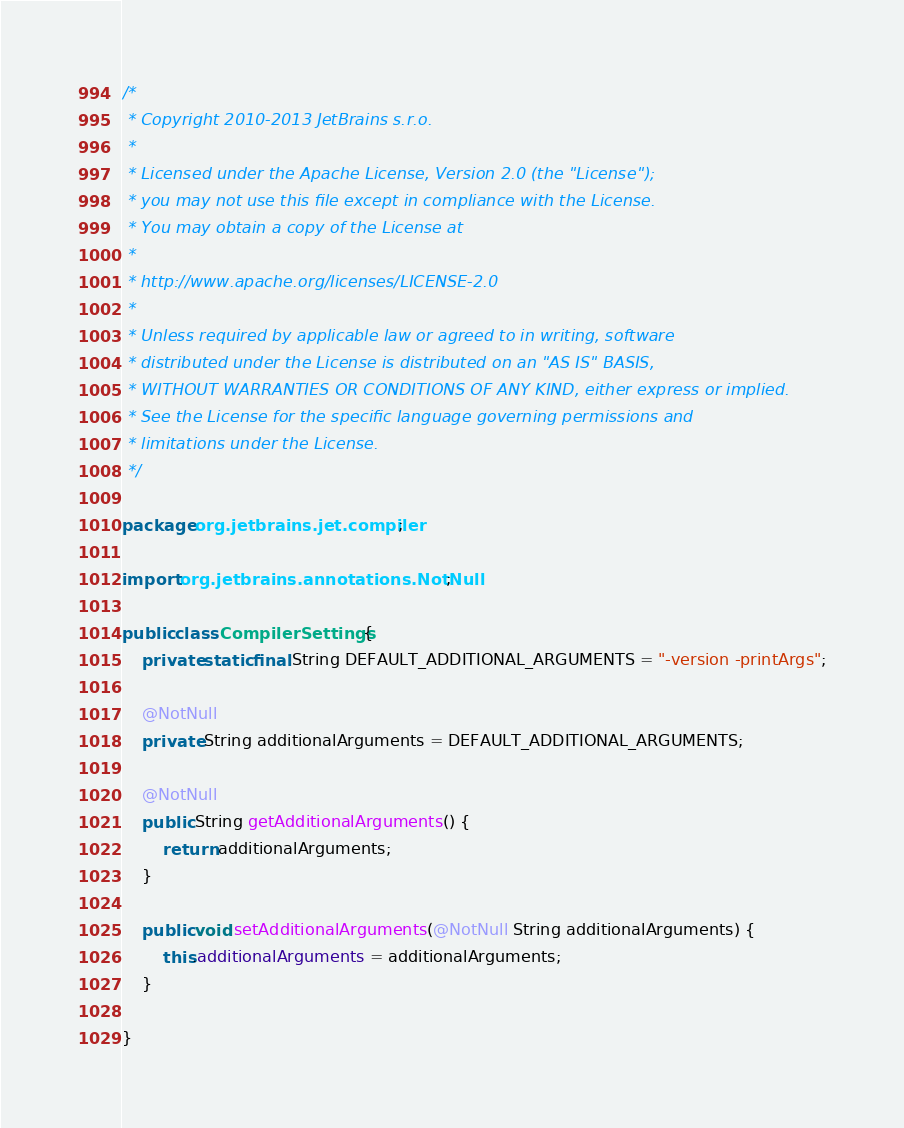Convert code to text. <code><loc_0><loc_0><loc_500><loc_500><_Java_>/*
 * Copyright 2010-2013 JetBrains s.r.o.
 *
 * Licensed under the Apache License, Version 2.0 (the "License");
 * you may not use this file except in compliance with the License.
 * You may obtain a copy of the License at
 *
 * http://www.apache.org/licenses/LICENSE-2.0
 *
 * Unless required by applicable law or agreed to in writing, software
 * distributed under the License is distributed on an "AS IS" BASIS,
 * WITHOUT WARRANTIES OR CONDITIONS OF ANY KIND, either express or implied.
 * See the License for the specific language governing permissions and
 * limitations under the License.
 */

package org.jetbrains.jet.compiler;

import org.jetbrains.annotations.NotNull;

public class CompilerSettings {
    private static final String DEFAULT_ADDITIONAL_ARGUMENTS = "-version -printArgs";

    @NotNull
    private String additionalArguments = DEFAULT_ADDITIONAL_ARGUMENTS;

    @NotNull
    public String getAdditionalArguments() {
        return additionalArguments;
    }

    public void setAdditionalArguments(@NotNull String additionalArguments) {
        this.additionalArguments = additionalArguments;
    }

}
</code> 